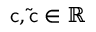Convert formula to latex. <formula><loc_0><loc_0><loc_500><loc_500>c , \tilde { c } \in \mathbb { R }</formula> 